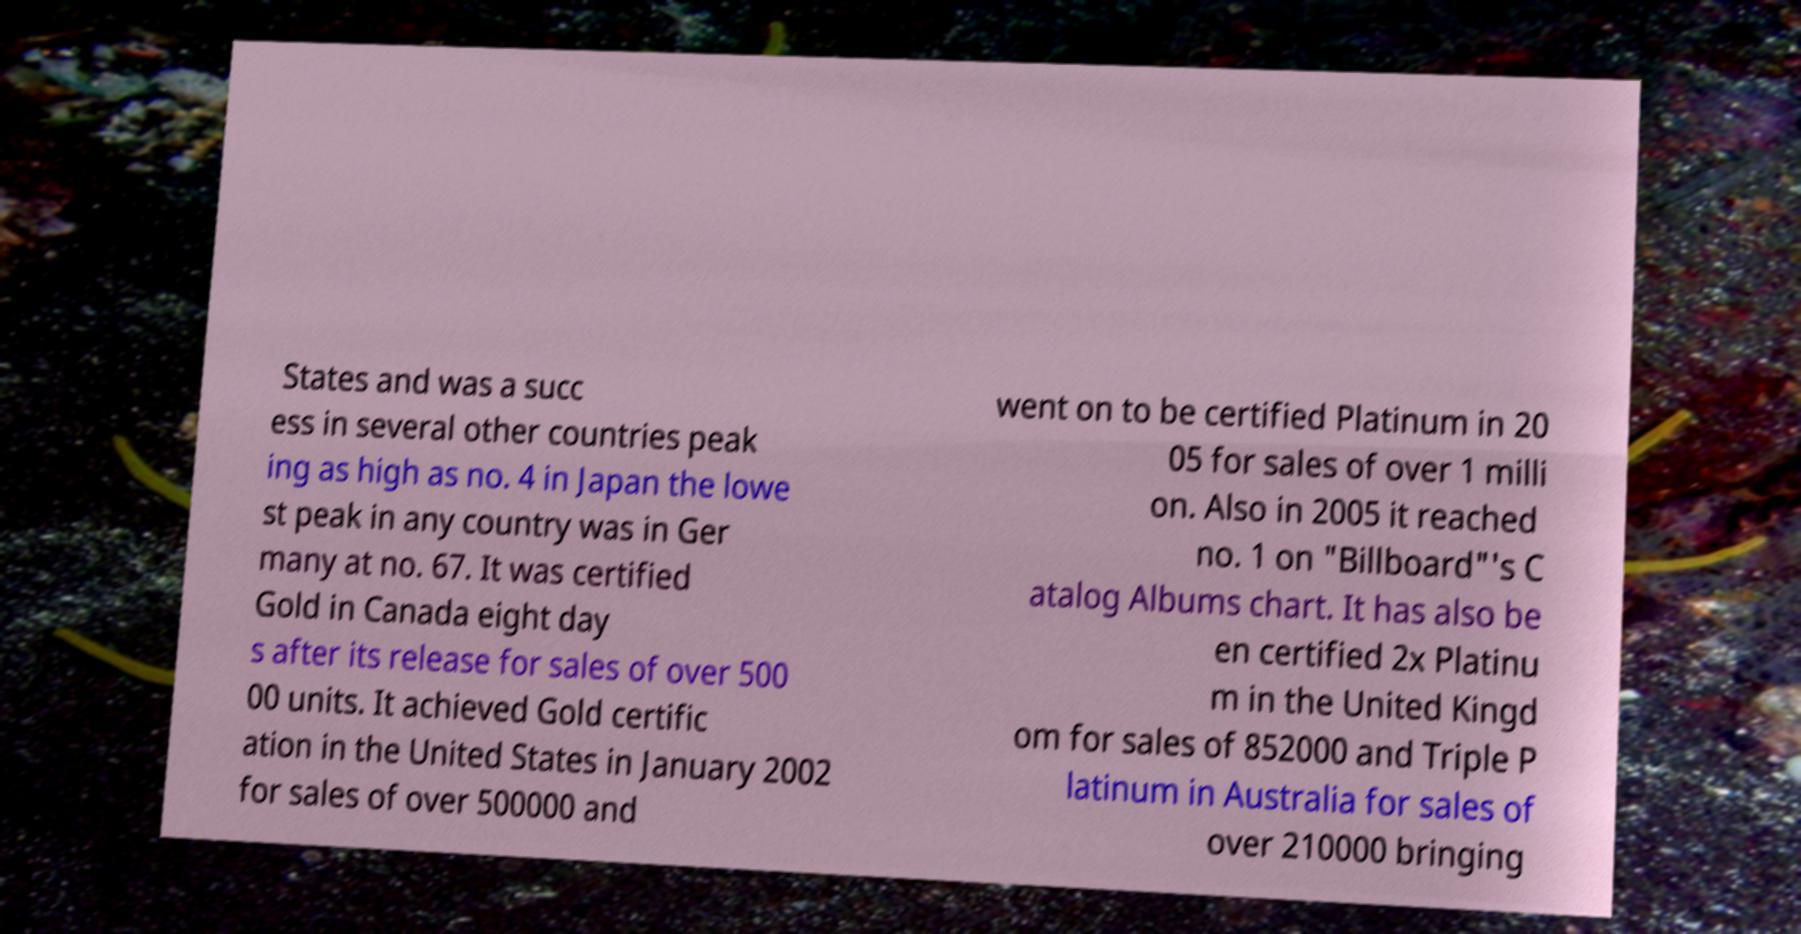I need the written content from this picture converted into text. Can you do that? States and was a succ ess in several other countries peak ing as high as no. 4 in Japan the lowe st peak in any country was in Ger many at no. 67. It was certified Gold in Canada eight day s after its release for sales of over 500 00 units. It achieved Gold certific ation in the United States in January 2002 for sales of over 500000 and went on to be certified Platinum in 20 05 for sales of over 1 milli on. Also in 2005 it reached no. 1 on "Billboard"'s C atalog Albums chart. It has also be en certified 2x Platinu m in the United Kingd om for sales of 852000 and Triple P latinum in Australia for sales of over 210000 bringing 